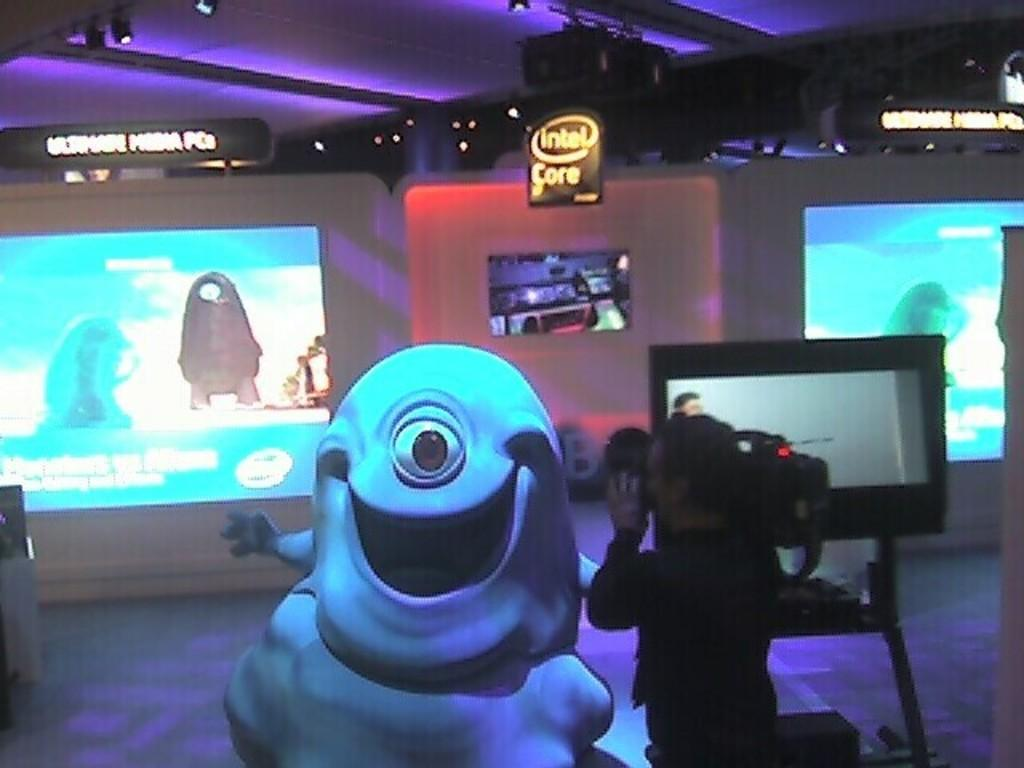<image>
Summarize the visual content of the image. a glob monster is being filmed under an intel core sign 